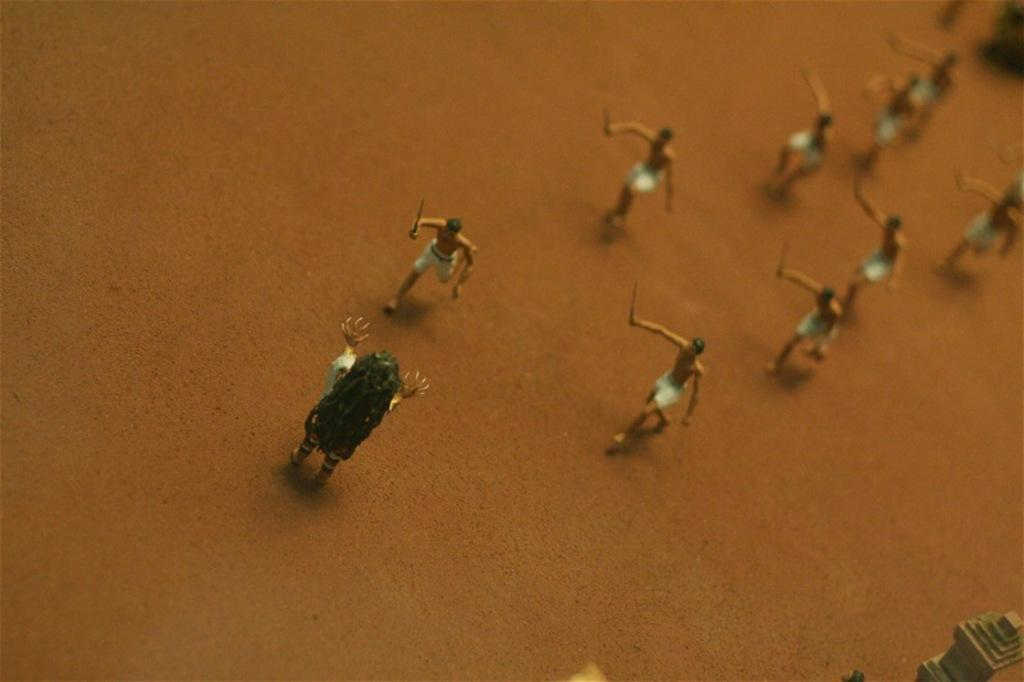What type of figures are present in the image? There are miniature persons in the image. Where are the miniature persons located? The miniature persons are on the ground. What type of corn can be seen growing in the image? There is no corn present in the image. What type of room are the miniature persons in? The provided facts do not mention a room, so it cannot be determined from the image. 